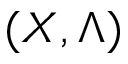<formula> <loc_0><loc_0><loc_500><loc_500>( X , \Lambda )</formula> 